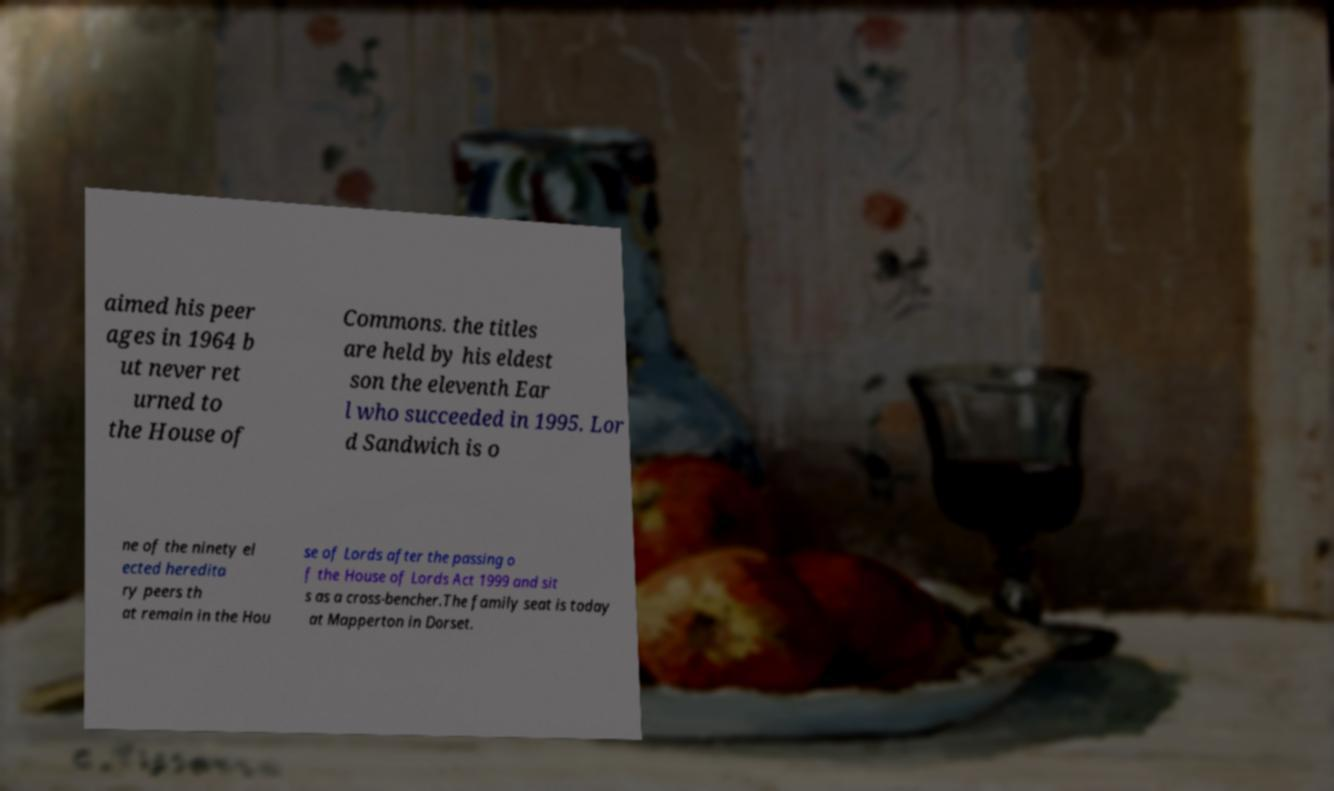What messages or text are displayed in this image? I need them in a readable, typed format. aimed his peer ages in 1964 b ut never ret urned to the House of Commons. the titles are held by his eldest son the eleventh Ear l who succeeded in 1995. Lor d Sandwich is o ne of the ninety el ected heredita ry peers th at remain in the Hou se of Lords after the passing o f the House of Lords Act 1999 and sit s as a cross-bencher.The family seat is today at Mapperton in Dorset. 